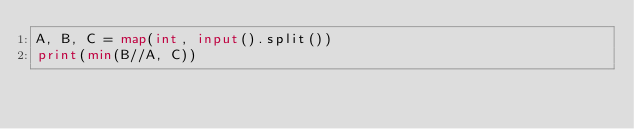<code> <loc_0><loc_0><loc_500><loc_500><_Python_>A, B, C = map(int, input().split())
print(min(B//A, C))</code> 